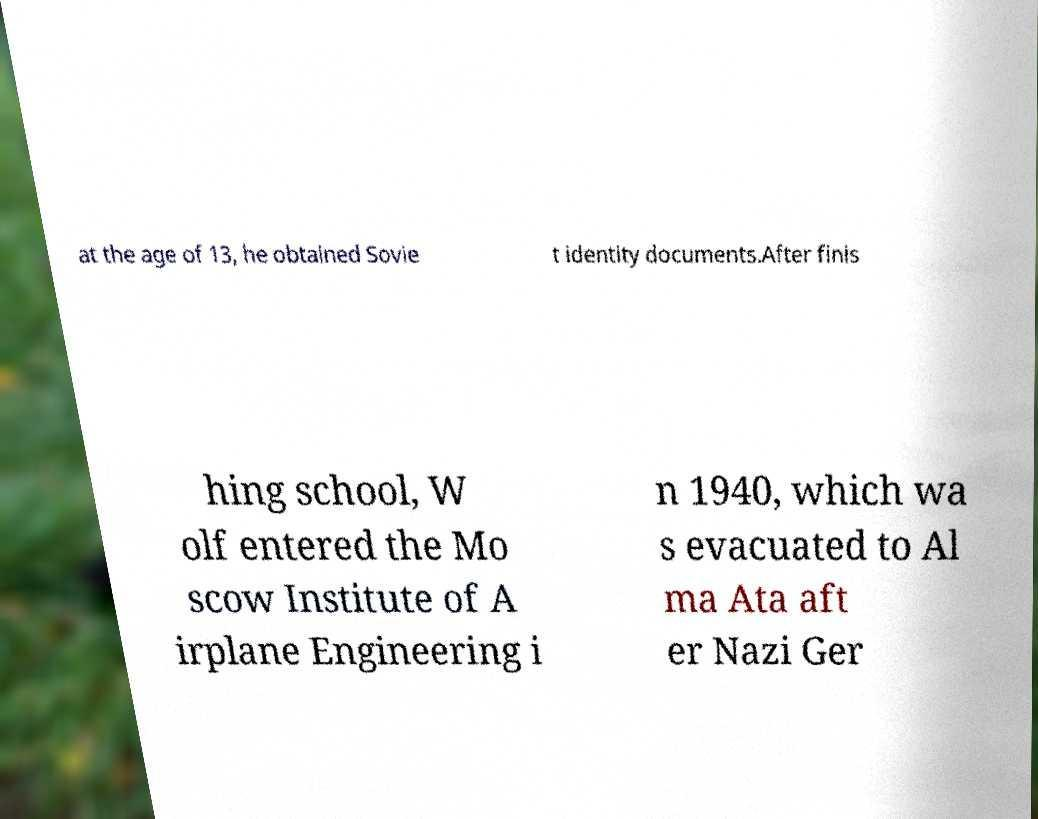Please read and relay the text visible in this image. What does it say? at the age of 13, he obtained Sovie t identity documents.After finis hing school, W olf entered the Mo scow Institute of A irplane Engineering i n 1940, which wa s evacuated to Al ma Ata aft er Nazi Ger 